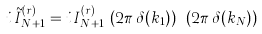<formula> <loc_0><loc_0><loc_500><loc_500>i \, \tilde { I } _ { N + 1 } ^ { ( r ) } = i \, I _ { N + 1 } ^ { ( r ) } \, \left ( 2 \pi \, \delta ( k _ { 1 } ) \right ) \cdots \left ( 2 \pi \, \delta ( k _ { N } ) \right )</formula> 